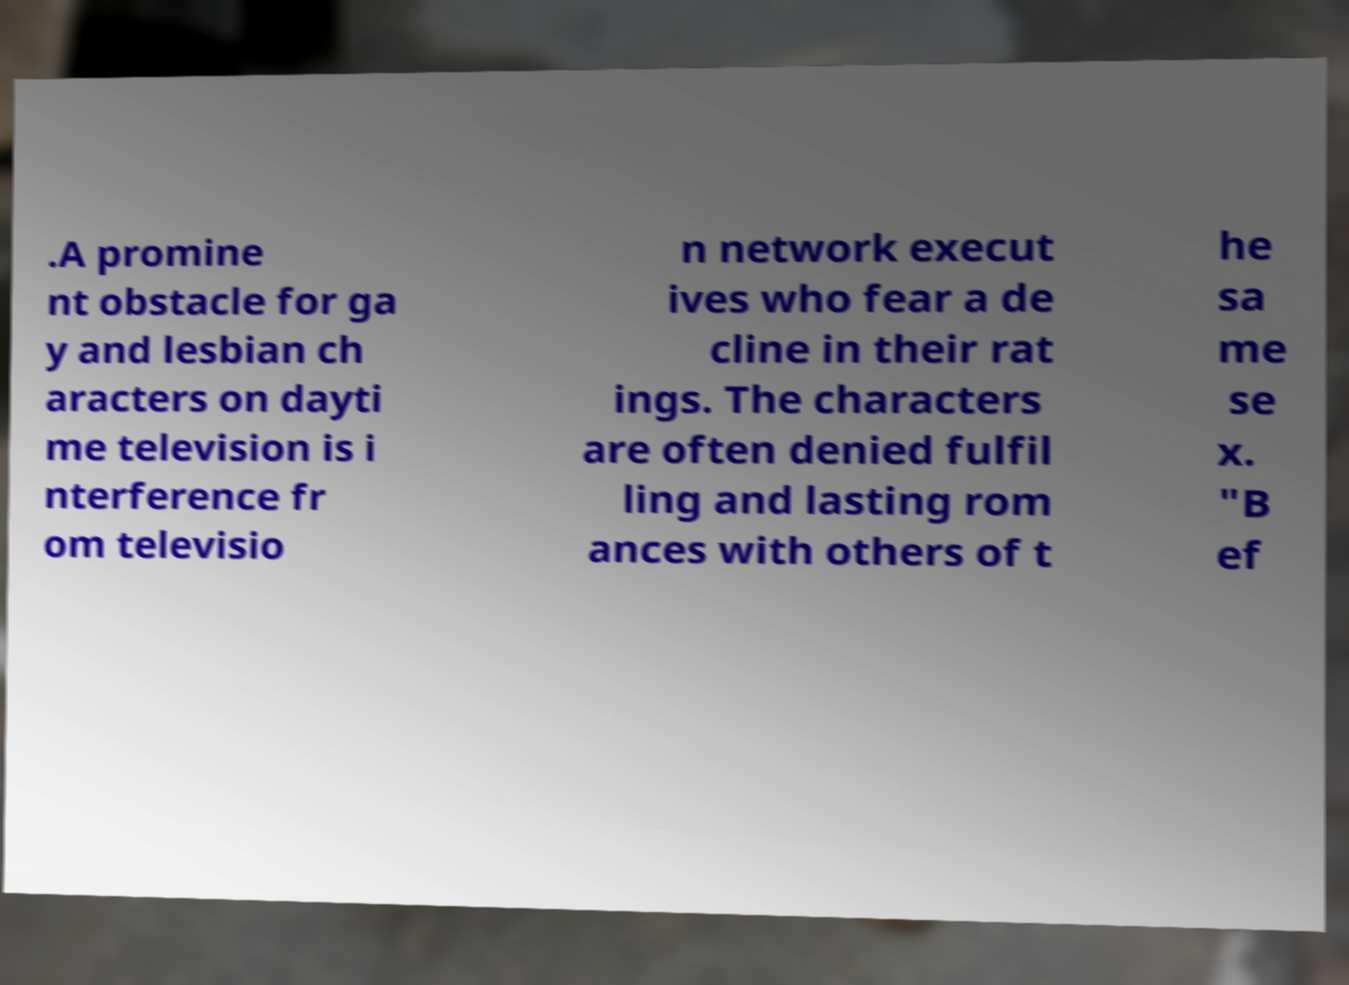Can you read and provide the text displayed in the image?This photo seems to have some interesting text. Can you extract and type it out for me? .A promine nt obstacle for ga y and lesbian ch aracters on dayti me television is i nterference fr om televisio n network execut ives who fear a de cline in their rat ings. The characters are often denied fulfil ling and lasting rom ances with others of t he sa me se x. "B ef 